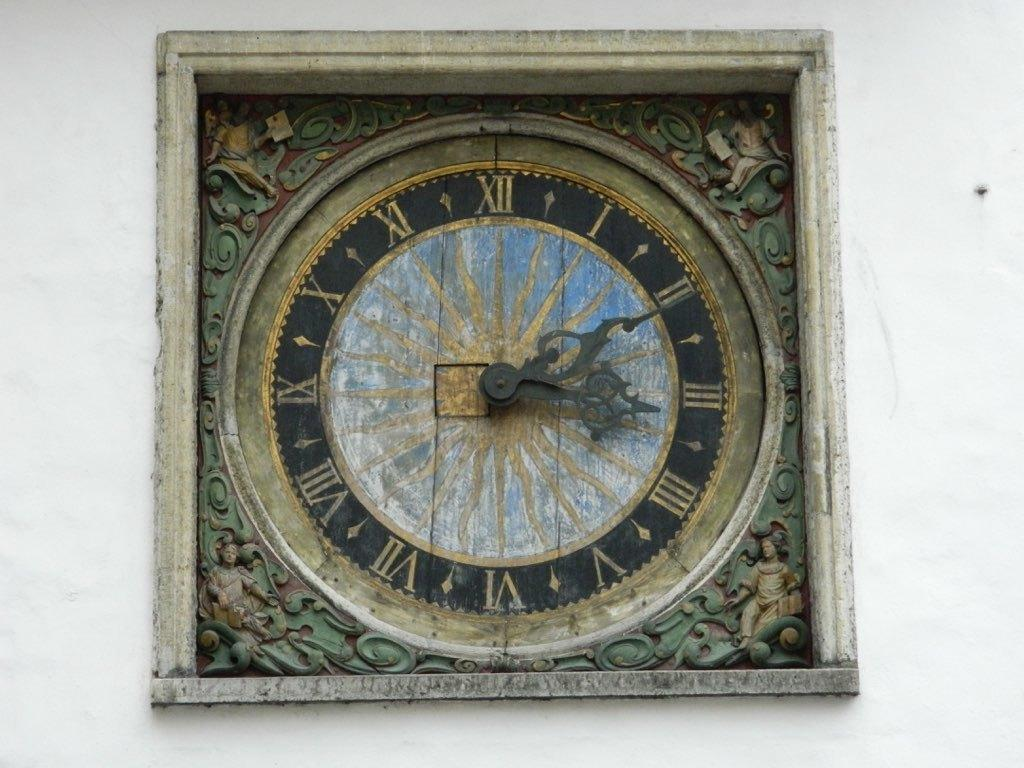<image>
Relay a brief, clear account of the picture shown. Unique clock which has the hands pointing at the numbers 2 and 3. 